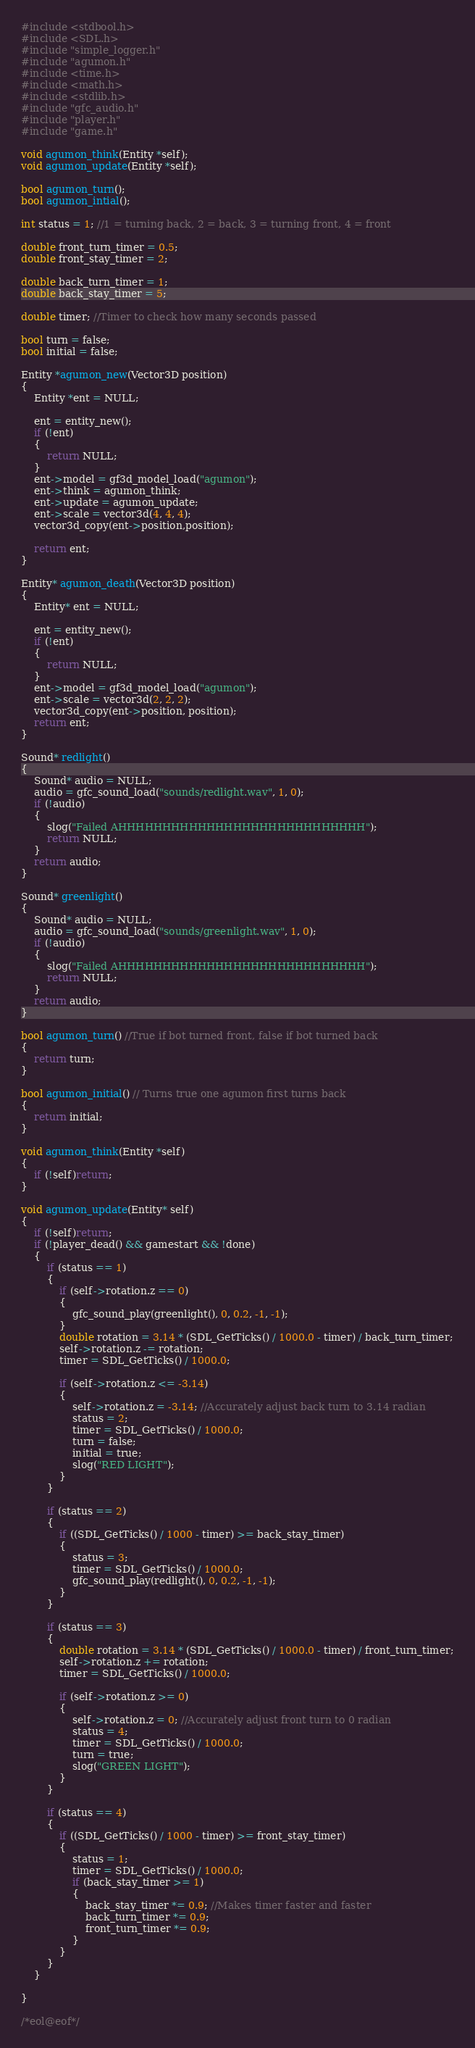<code> <loc_0><loc_0><loc_500><loc_500><_C_>#include <stdbool.h>
#include <SDL.h>
#include "simple_logger.h"
#include "agumon.h"
#include <time.h>
#include <math.h>
#include <stdlib.h>
#include "gfc_audio.h"
#include "player.h"
#include "game.h"

void agumon_think(Entity *self);
void agumon_update(Entity *self);

bool agumon_turn();
bool agumon_intial();

int status = 1; //1 = turning back, 2 = back, 3 = turning front, 4 = front

double front_turn_timer = 0.5;
double front_stay_timer = 2;

double back_turn_timer = 1;
double back_stay_timer = 5;

double timer; //Timer to check how many seconds passed 

bool turn = false;
bool initial = false;

Entity *agumon_new(Vector3D position)
{
    Entity *ent = NULL;
    
    ent = entity_new();
    if (!ent)
    {
        return NULL;
    }
    ent->model = gf3d_model_load("agumon");
    ent->think = agumon_think;
    ent->update = agumon_update;
    ent->scale = vector3d(4, 4, 4);
    vector3d_copy(ent->position,position);

    return ent;
}

Entity* agumon_death(Vector3D position)
{
    Entity* ent = NULL;

    ent = entity_new();
    if (!ent)
    {
        return NULL;
    }
    ent->model = gf3d_model_load("agumon");
    ent->scale = vector3d(2, 2, 2);
    vector3d_copy(ent->position, position);
    return ent;
}

Sound* redlight()
{
    Sound* audio = NULL;
    audio = gfc_sound_load("sounds/redlight.wav", 1, 0);
    if (!audio)
    {
        slog("Failed AHHHHHHHHHHHHHHHHHHHHHHHHHHHH");
        return NULL;
    }
    return audio;
}

Sound* greenlight()
{
    Sound* audio = NULL;
    audio = gfc_sound_load("sounds/greenlight.wav", 1, 0);
    if (!audio)
    {
        slog("Failed AHHHHHHHHHHHHHHHHHHHHHHHHHHHH");
        return NULL;
    }
    return audio;
}

bool agumon_turn() //True if bot turned front, false if bot turned back
{
    return turn;
}

bool agumon_initial() // Turns true one agumon first turns back
{
    return initial;
}

void agumon_think(Entity *self)
{
    if (!self)return;
}

void agumon_update(Entity* self)
{
    if (!self)return;
    if (!player_dead() && gamestart && !done)
    {
        if (status == 1)
        {
            if (self->rotation.z == 0)
            {
                gfc_sound_play(greenlight(), 0, 0.2, -1, -1);
            }
            double rotation = 3.14 * (SDL_GetTicks() / 1000.0 - timer) / back_turn_timer;
            self->rotation.z -= rotation;
            timer = SDL_GetTicks() / 1000.0;

            if (self->rotation.z <= -3.14)
            {
                self->rotation.z = -3.14; //Accurately adjust back turn to 3.14 radian
                status = 2;
                timer = SDL_GetTicks() / 1000.0;
                turn = false;
                initial = true;
                slog("RED LIGHT");
            }
        }

        if (status == 2)
        {
            if ((SDL_GetTicks() / 1000 - timer) >= back_stay_timer)
            {
                status = 3;
                timer = SDL_GetTicks() / 1000.0;
                gfc_sound_play(redlight(), 0, 0.2, -1, -1);
            }
        }

        if (status == 3)
        {
            double rotation = 3.14 * (SDL_GetTicks() / 1000.0 - timer) / front_turn_timer;
            self->rotation.z += rotation;
            timer = SDL_GetTicks() / 1000.0;

            if (self->rotation.z >= 0)
            {
                self->rotation.z = 0; //Accurately adjust front turn to 0 radian
                status = 4;
                timer = SDL_GetTicks() / 1000.0;
                turn = true;
                slog("GREEN LIGHT");
            }
        }

        if (status == 4)
        {
            if ((SDL_GetTicks() / 1000 - timer) >= front_stay_timer)
            {
                status = 1;
                timer = SDL_GetTicks() / 1000.0;
                if (back_stay_timer >= 1)
                {
                    back_stay_timer *= 0.9; //Makes timer faster and faster 
                    back_turn_timer *= 0.9;
                    front_turn_timer *= 0.9;
                }
            }
        }
    }
    
}

/*eol@eof*/
</code> 